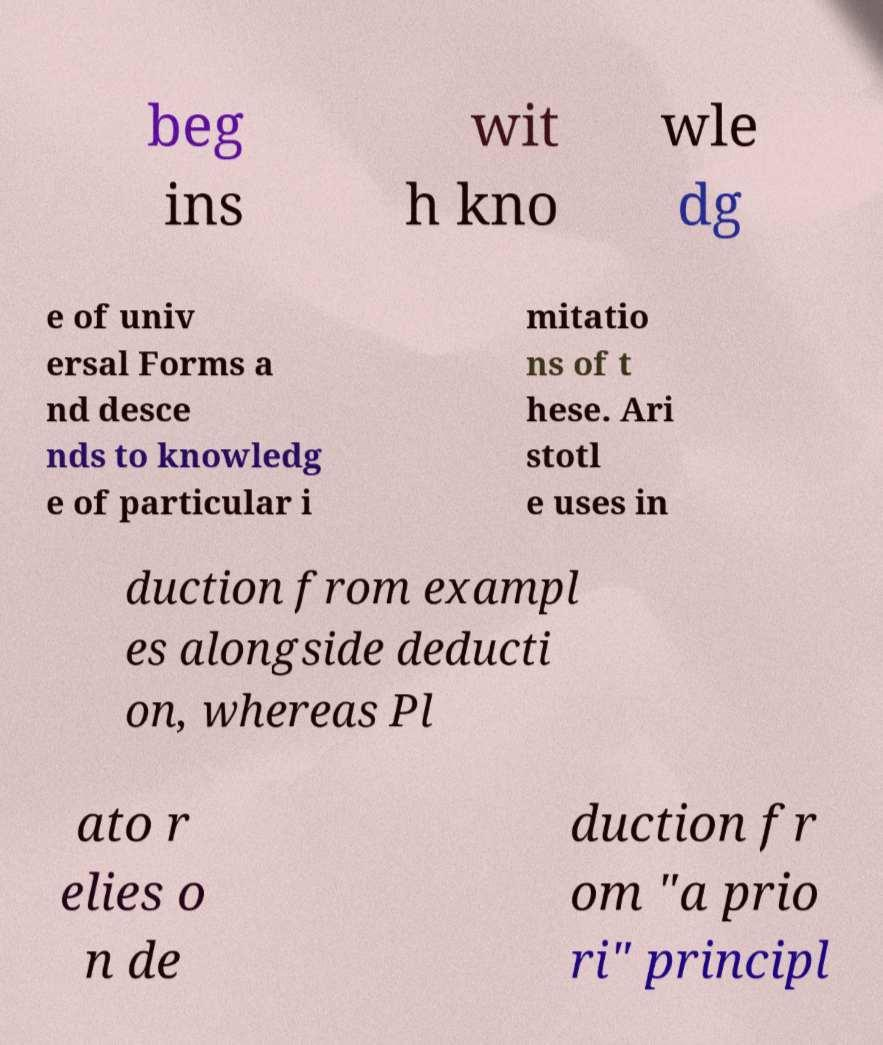I need the written content from this picture converted into text. Can you do that? beg ins wit h kno wle dg e of univ ersal Forms a nd desce nds to knowledg e of particular i mitatio ns of t hese. Ari stotl e uses in duction from exampl es alongside deducti on, whereas Pl ato r elies o n de duction fr om "a prio ri" principl 